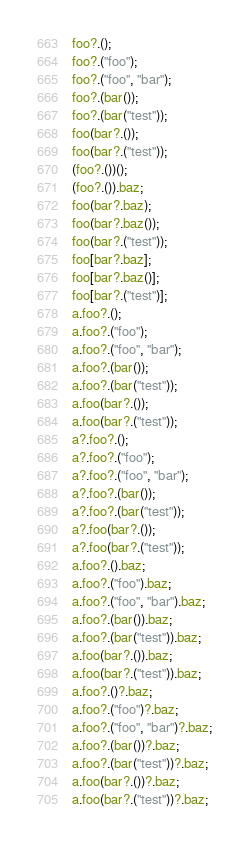Convert code to text. <code><loc_0><loc_0><loc_500><loc_500><_JavaScript_>foo?.();
foo?.("foo");
foo?.("foo", "bar");
foo?.(bar());
foo?.(bar("test"));
foo(bar?.());
foo(bar?.("test"));
(foo?.())();
(foo?.()).baz;
foo(bar?.baz);
foo(bar?.baz());
foo(bar?.("test"));
foo[bar?.baz];
foo[bar?.baz()];
foo[bar?.("test")];
a.foo?.();
a.foo?.("foo");
a.foo?.("foo", "bar");
a.foo?.(bar());
a.foo?.(bar("test"));
a.foo(bar?.());
a.foo(bar?.("test"));
a?.foo?.();
a?.foo?.("foo");
a?.foo?.("foo", "bar");
a?.foo?.(bar());
a?.foo?.(bar("test"));
a?.foo(bar?.());
a?.foo(bar?.("test"));
a.foo?.().baz;
a.foo?.("foo").baz;
a.foo?.("foo", "bar").baz;
a.foo?.(bar()).baz;
a.foo?.(bar("test")).baz;
a.foo(bar?.()).baz;
a.foo(bar?.("test")).baz;
a.foo?.()?.baz;
a.foo?.("foo")?.baz;
a.foo?.("foo", "bar")?.baz;
a.foo?.(bar())?.baz;
a.foo?.(bar("test"))?.baz;
a.foo(bar?.())?.baz;
a.foo(bar?.("test"))?.baz;</code> 